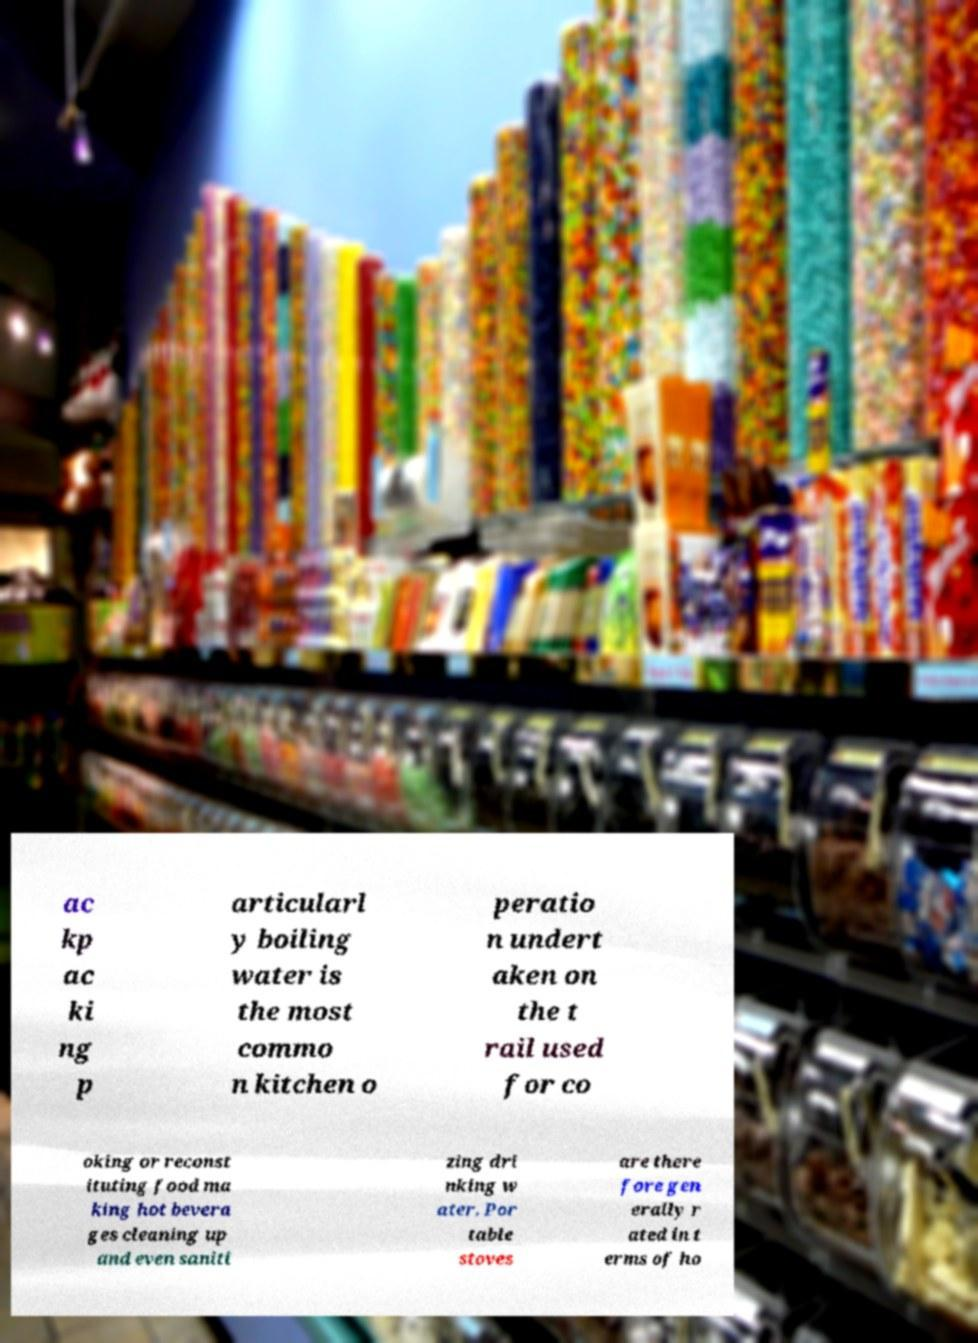Could you extract and type out the text from this image? ac kp ac ki ng p articularl y boiling water is the most commo n kitchen o peratio n undert aken on the t rail used for co oking or reconst ituting food ma king hot bevera ges cleaning up and even saniti zing dri nking w ater. Por table stoves are there fore gen erally r ated in t erms of ho 